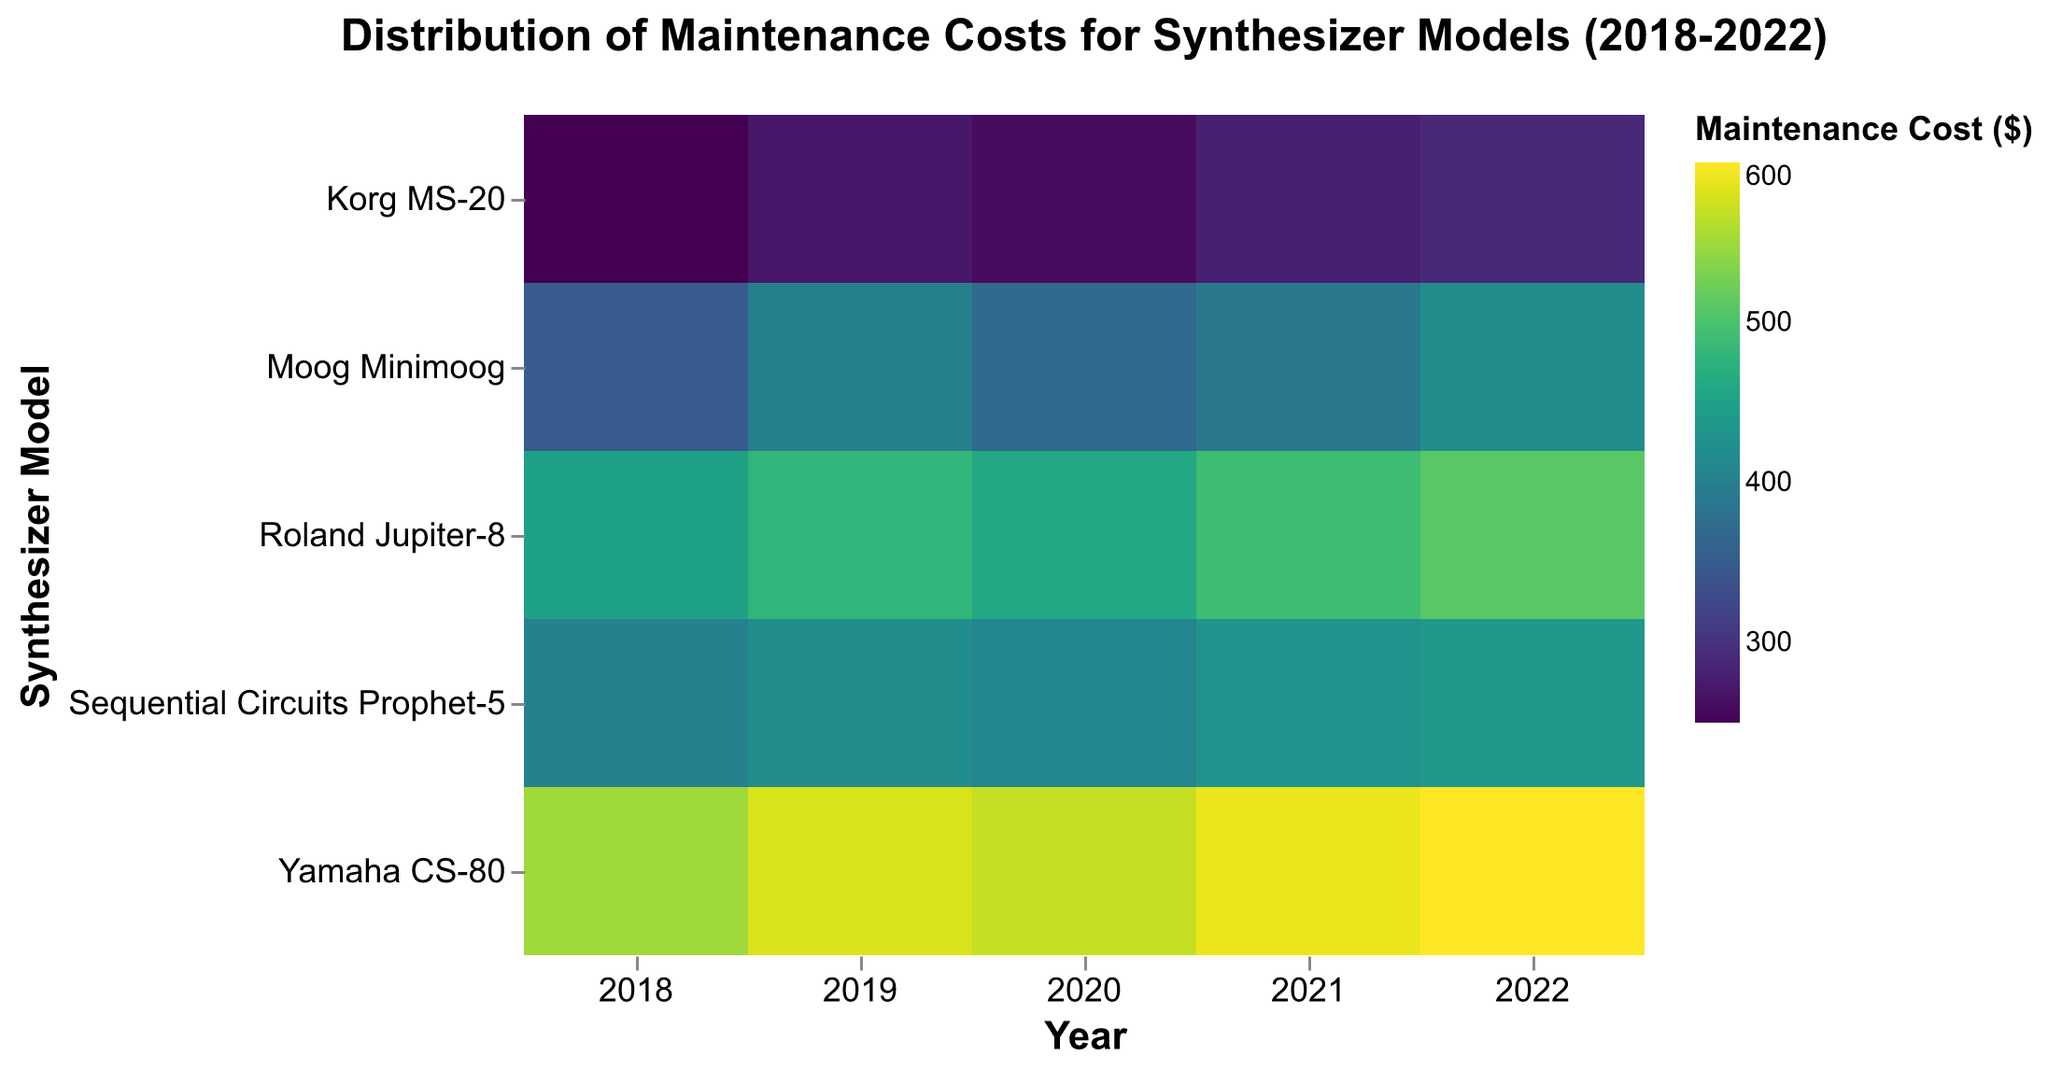What is the title of the heatmap? The title of the heatmap is usually displayed prominently at the top of the figure. In this case, it reads "Distribution of Maintenance Costs for Synthesizer Models (2018-2022)."
Answer: Distribution of Maintenance Costs for Synthesizer Models (2018-2022) What are the axes labels in the heatmap? The x-axis, which runs horizontally, is labeled "Year," and the y-axis, which runs vertically, is labeled "Synthesizer Model."
Answer: Year, Synthesizer Model Which synthesizer model has the highest maintenance cost in 2022? To answer this, find the year 2022 on the x-axis and compare the color intensities of the corresponding cells. The darkest cell represents the highest cost. The Yamaha CS-80 has the darkest cell in 2022, indicating the highest maintenance cost of $600.
Answer: Yamaha CS-80 What is the maintenance cost trend for the Moog Minimoog from 2018 to 2022? Look along the row for the Moog Minimoog and observe the color changes year by year. The colors become progressively darker from 2018 to 2022, indicating an increasing maintenance cost.
Answer: Increasing Compare the maintenance costs of the Korg MS-20 and Roland Jupiter-8 in 2020. Which is higher? Find the year 2020 on the x-axis and trace it to the rows for Korg MS-20 and Roland Jupiter-8. The Korg MS-20 shows a lighter color than the Roland Jupiter-8 in 2020, so the maintenance cost for the Roland Jupiter-8 is higher.
Answer: Roland Jupiter-8 What is the average maintenance cost for the Sequential Circuits Prophet-5 over the years displayed? Sum the maintenance costs for each year and divide by the number of years: (400 + 420 + 410 + 430 + 440) / 5. That's (400 + 420 + 410 + 430 + 440 = 2100; 2100 / 5 = 420).
Answer: $420 Which synthesizer model has the most consistently high maintenance costs over the period? Look for the model with the least variation in color intensity across all years. The Yamaha CS-80 consistently shows very dark cells, indicating consistently high maintenance costs.
Answer: Yamaha CS-80 Identify the year with the highest total maintenance cost across all synthesizer models. Add up the maintenance costs for each year across all models and find the year with the highest sum. For example: 2018: 350+450+250+400+550; 2019: 400+480+270+420+580 (and so on), then compare sums.
Answer: 2022 Is there a model with decreasing maintenance costs over the years? Observe each row to see if the color intensity decreases from left to right. In this heatmap, none of the models have decreasing maintenance costs; all either increase or remain relatively constant.
Answer: No How does the maintenance cost of the Yamaha CS-80 in 2020 compare to the Moog Minimoog in 2020? Find the year 2020 on the x-axis and compare the corresponding cells for Yamaha CS-80 and Moog Minimoog. The Yamaha CS-80 is darker, indicating a higher cost.
Answer: Yamaha CS-80 is higher 